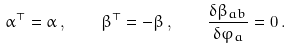<formula> <loc_0><loc_0><loc_500><loc_500>\alpha ^ { \top } = \alpha \, , \quad \beta ^ { \top } = - \beta \, , \quad \frac { \delta \beta _ { a b } } { \delta \varphi _ { a } } = 0 \, .</formula> 